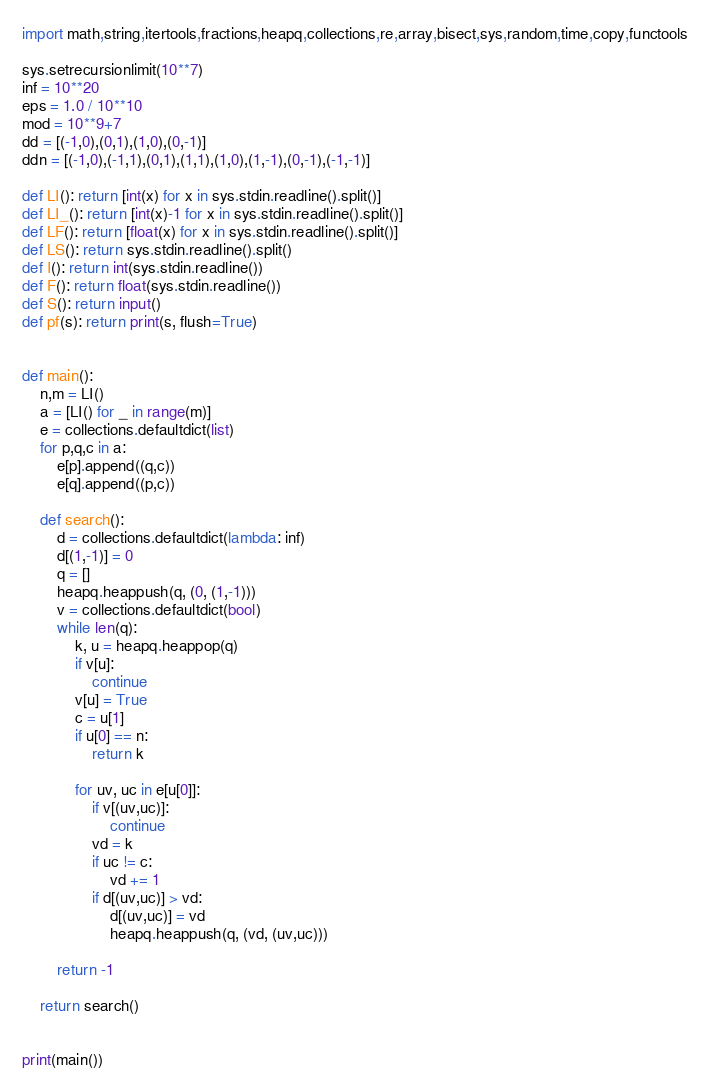Convert code to text. <code><loc_0><loc_0><loc_500><loc_500><_Python_>import math,string,itertools,fractions,heapq,collections,re,array,bisect,sys,random,time,copy,functools

sys.setrecursionlimit(10**7)
inf = 10**20
eps = 1.0 / 10**10
mod = 10**9+7
dd = [(-1,0),(0,1),(1,0),(0,-1)]
ddn = [(-1,0),(-1,1),(0,1),(1,1),(1,0),(1,-1),(0,-1),(-1,-1)]

def LI(): return [int(x) for x in sys.stdin.readline().split()]
def LI_(): return [int(x)-1 for x in sys.stdin.readline().split()]
def LF(): return [float(x) for x in sys.stdin.readline().split()]
def LS(): return sys.stdin.readline().split()
def I(): return int(sys.stdin.readline())
def F(): return float(sys.stdin.readline())
def S(): return input()
def pf(s): return print(s, flush=True)


def main():
    n,m = LI()
    a = [LI() for _ in range(m)]
    e = collections.defaultdict(list)
    for p,q,c in a:
        e[p].append((q,c))
        e[q].append((p,c))

    def search():
        d = collections.defaultdict(lambda: inf)
        d[(1,-1)] = 0
        q = []
        heapq.heappush(q, (0, (1,-1)))
        v = collections.defaultdict(bool)
        while len(q):
            k, u = heapq.heappop(q)
            if v[u]:
                continue
            v[u] = True
            c = u[1]
            if u[0] == n:
                return k

            for uv, uc in e[u[0]]:
                if v[(uv,uc)]:
                    continue
                vd = k
                if uc != c:
                    vd += 1
                if d[(uv,uc)] > vd:
                    d[(uv,uc)] = vd
                    heapq.heappush(q, (vd, (uv,uc)))

        return -1

    return search()


print(main())
</code> 